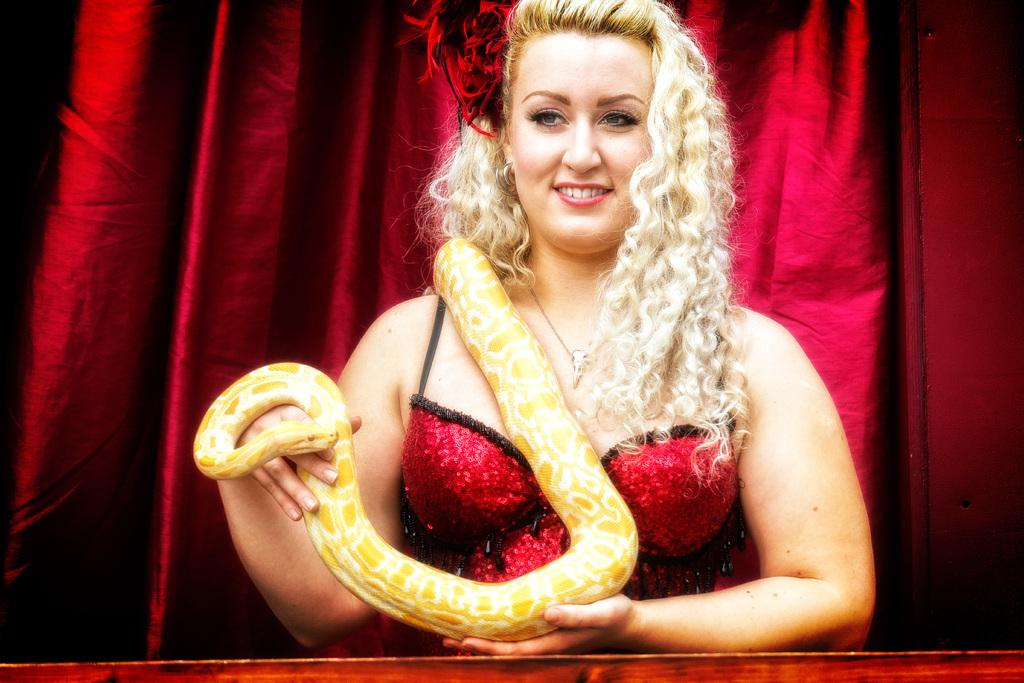Who is present in the image? There is a woman in the image. What is the woman wearing? The woman is wearing a red dress. What is the woman holding in the image? The woman is holding a snake. What color is the curtain in the image? There is a red curtain in the image. What type of bread can be seen in the woman's hand in the image? There is no bread present in the image; the woman is holding a snake. 